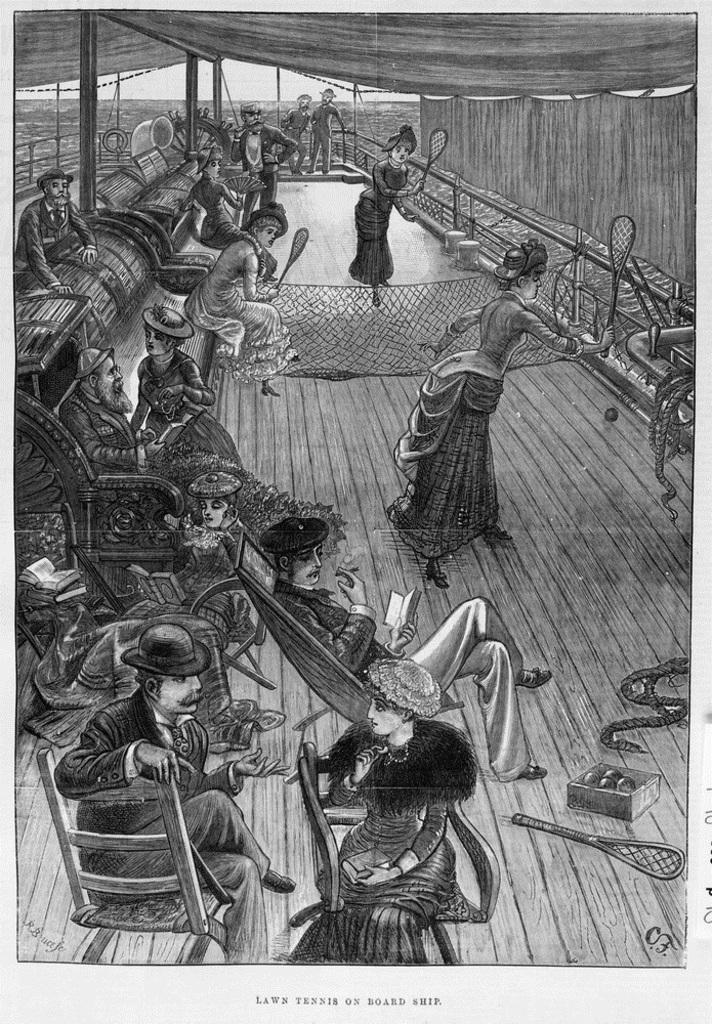Please provide a concise description of this image. This is a black and white image. In this image we can see a painting. There are many people sitting. Few are standing. Few are holding bats and playing. And there is a net. And people are wearing caps. And one person is holding a book. On the floor there is a box with balls and bat. And there are ropes. And few persons are sitting on chairs. 